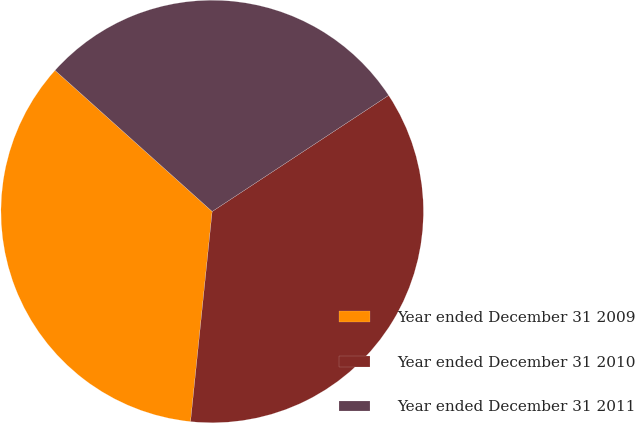Convert chart to OTSL. <chart><loc_0><loc_0><loc_500><loc_500><pie_chart><fcel>Year ended December 31 2009<fcel>Year ended December 31 2010<fcel>Year ended December 31 2011<nl><fcel>35.01%<fcel>35.89%<fcel>29.09%<nl></chart> 